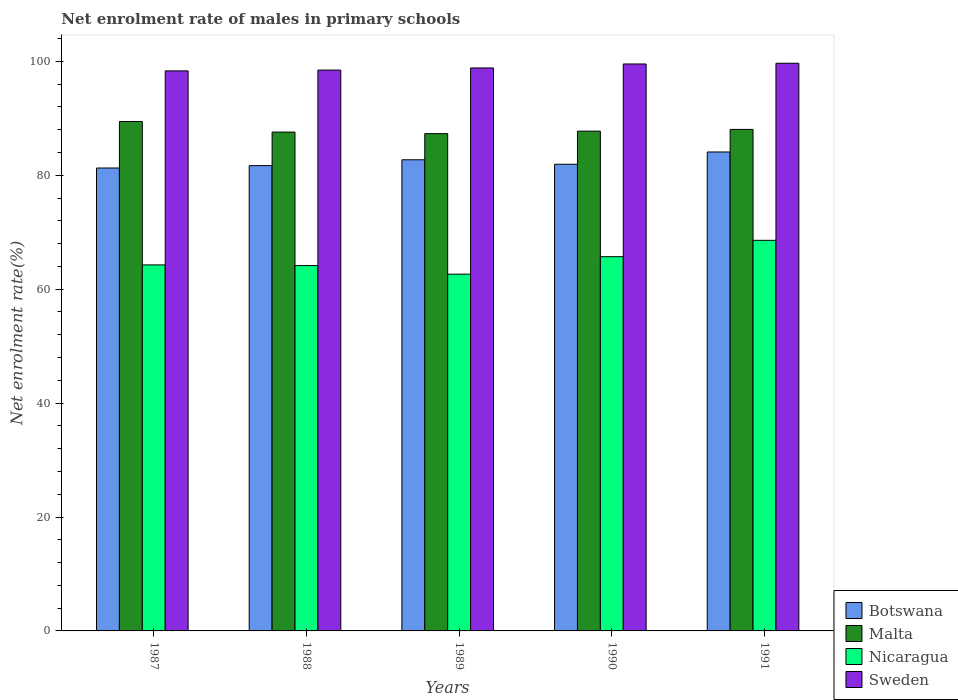How many groups of bars are there?
Your answer should be compact. 5. Are the number of bars on each tick of the X-axis equal?
Provide a short and direct response. Yes. How many bars are there on the 4th tick from the right?
Offer a terse response. 4. What is the label of the 3rd group of bars from the left?
Provide a succinct answer. 1989. What is the net enrolment rate of males in primary schools in Botswana in 1990?
Keep it short and to the point. 81.93. Across all years, what is the maximum net enrolment rate of males in primary schools in Nicaragua?
Ensure brevity in your answer.  68.58. Across all years, what is the minimum net enrolment rate of males in primary schools in Nicaragua?
Your answer should be compact. 62.63. In which year was the net enrolment rate of males in primary schools in Botswana maximum?
Provide a succinct answer. 1991. In which year was the net enrolment rate of males in primary schools in Sweden minimum?
Provide a short and direct response. 1987. What is the total net enrolment rate of males in primary schools in Botswana in the graph?
Provide a succinct answer. 411.7. What is the difference between the net enrolment rate of males in primary schools in Nicaragua in 1989 and that in 1991?
Offer a very short reply. -5.94. What is the difference between the net enrolment rate of males in primary schools in Botswana in 1988 and the net enrolment rate of males in primary schools in Sweden in 1990?
Your answer should be compact. -17.84. What is the average net enrolment rate of males in primary schools in Nicaragua per year?
Ensure brevity in your answer.  65.06. In the year 1991, what is the difference between the net enrolment rate of males in primary schools in Sweden and net enrolment rate of males in primary schools in Malta?
Offer a very short reply. 11.62. In how many years, is the net enrolment rate of males in primary schools in Botswana greater than 92 %?
Your answer should be compact. 0. What is the ratio of the net enrolment rate of males in primary schools in Malta in 1989 to that in 1991?
Offer a terse response. 0.99. Is the net enrolment rate of males in primary schools in Nicaragua in 1990 less than that in 1991?
Make the answer very short. Yes. What is the difference between the highest and the second highest net enrolment rate of males in primary schools in Nicaragua?
Ensure brevity in your answer.  2.87. What is the difference between the highest and the lowest net enrolment rate of males in primary schools in Botswana?
Provide a short and direct response. 2.81. In how many years, is the net enrolment rate of males in primary schools in Malta greater than the average net enrolment rate of males in primary schools in Malta taken over all years?
Your response must be concise. 2. Is the sum of the net enrolment rate of males in primary schools in Malta in 1988 and 1989 greater than the maximum net enrolment rate of males in primary schools in Sweden across all years?
Give a very brief answer. Yes. What does the 4th bar from the right in 1989 represents?
Offer a very short reply. Botswana. How many bars are there?
Your response must be concise. 20. Are all the bars in the graph horizontal?
Keep it short and to the point. No. How many years are there in the graph?
Give a very brief answer. 5. Are the values on the major ticks of Y-axis written in scientific E-notation?
Your answer should be compact. No. How many legend labels are there?
Give a very brief answer. 4. What is the title of the graph?
Your answer should be very brief. Net enrolment rate of males in primary schools. What is the label or title of the Y-axis?
Offer a very short reply. Net enrolment rate(%). What is the Net enrolment rate(%) in Botswana in 1987?
Offer a very short reply. 81.27. What is the Net enrolment rate(%) in Malta in 1987?
Provide a succinct answer. 89.44. What is the Net enrolment rate(%) of Nicaragua in 1987?
Ensure brevity in your answer.  64.26. What is the Net enrolment rate(%) of Sweden in 1987?
Keep it short and to the point. 98.32. What is the Net enrolment rate(%) in Botswana in 1988?
Your response must be concise. 81.69. What is the Net enrolment rate(%) in Malta in 1988?
Your answer should be compact. 87.58. What is the Net enrolment rate(%) of Nicaragua in 1988?
Offer a terse response. 64.14. What is the Net enrolment rate(%) in Sweden in 1988?
Your answer should be compact. 98.47. What is the Net enrolment rate(%) of Botswana in 1989?
Keep it short and to the point. 82.72. What is the Net enrolment rate(%) in Malta in 1989?
Your answer should be very brief. 87.31. What is the Net enrolment rate(%) of Nicaragua in 1989?
Offer a terse response. 62.63. What is the Net enrolment rate(%) in Sweden in 1989?
Your response must be concise. 98.84. What is the Net enrolment rate(%) in Botswana in 1990?
Provide a short and direct response. 81.93. What is the Net enrolment rate(%) in Malta in 1990?
Your response must be concise. 87.74. What is the Net enrolment rate(%) of Nicaragua in 1990?
Your response must be concise. 65.71. What is the Net enrolment rate(%) in Sweden in 1990?
Give a very brief answer. 99.54. What is the Net enrolment rate(%) in Botswana in 1991?
Make the answer very short. 84.09. What is the Net enrolment rate(%) in Malta in 1991?
Keep it short and to the point. 88.05. What is the Net enrolment rate(%) in Nicaragua in 1991?
Ensure brevity in your answer.  68.58. What is the Net enrolment rate(%) in Sweden in 1991?
Your answer should be compact. 99.66. Across all years, what is the maximum Net enrolment rate(%) of Botswana?
Your answer should be very brief. 84.09. Across all years, what is the maximum Net enrolment rate(%) of Malta?
Provide a succinct answer. 89.44. Across all years, what is the maximum Net enrolment rate(%) of Nicaragua?
Your response must be concise. 68.58. Across all years, what is the maximum Net enrolment rate(%) in Sweden?
Your response must be concise. 99.66. Across all years, what is the minimum Net enrolment rate(%) of Botswana?
Provide a short and direct response. 81.27. Across all years, what is the minimum Net enrolment rate(%) of Malta?
Keep it short and to the point. 87.31. Across all years, what is the minimum Net enrolment rate(%) in Nicaragua?
Your response must be concise. 62.63. Across all years, what is the minimum Net enrolment rate(%) of Sweden?
Your answer should be very brief. 98.32. What is the total Net enrolment rate(%) of Botswana in the graph?
Give a very brief answer. 411.7. What is the total Net enrolment rate(%) in Malta in the graph?
Your response must be concise. 440.12. What is the total Net enrolment rate(%) of Nicaragua in the graph?
Ensure brevity in your answer.  325.31. What is the total Net enrolment rate(%) of Sweden in the graph?
Provide a short and direct response. 494.83. What is the difference between the Net enrolment rate(%) in Botswana in 1987 and that in 1988?
Ensure brevity in your answer.  -0.42. What is the difference between the Net enrolment rate(%) of Malta in 1987 and that in 1988?
Your answer should be compact. 1.86. What is the difference between the Net enrolment rate(%) of Nicaragua in 1987 and that in 1988?
Keep it short and to the point. 0.12. What is the difference between the Net enrolment rate(%) of Sweden in 1987 and that in 1988?
Provide a succinct answer. -0.14. What is the difference between the Net enrolment rate(%) in Botswana in 1987 and that in 1989?
Offer a terse response. -1.44. What is the difference between the Net enrolment rate(%) in Malta in 1987 and that in 1989?
Offer a terse response. 2.13. What is the difference between the Net enrolment rate(%) in Nicaragua in 1987 and that in 1989?
Provide a succinct answer. 1.62. What is the difference between the Net enrolment rate(%) of Sweden in 1987 and that in 1989?
Make the answer very short. -0.52. What is the difference between the Net enrolment rate(%) of Botswana in 1987 and that in 1990?
Provide a short and direct response. -0.66. What is the difference between the Net enrolment rate(%) of Malta in 1987 and that in 1990?
Your answer should be very brief. 1.7. What is the difference between the Net enrolment rate(%) in Nicaragua in 1987 and that in 1990?
Ensure brevity in your answer.  -1.45. What is the difference between the Net enrolment rate(%) in Sweden in 1987 and that in 1990?
Keep it short and to the point. -1.21. What is the difference between the Net enrolment rate(%) of Botswana in 1987 and that in 1991?
Provide a short and direct response. -2.81. What is the difference between the Net enrolment rate(%) in Malta in 1987 and that in 1991?
Your response must be concise. 1.39. What is the difference between the Net enrolment rate(%) in Nicaragua in 1987 and that in 1991?
Provide a succinct answer. -4.32. What is the difference between the Net enrolment rate(%) of Sweden in 1987 and that in 1991?
Offer a very short reply. -1.34. What is the difference between the Net enrolment rate(%) in Botswana in 1988 and that in 1989?
Your answer should be very brief. -1.03. What is the difference between the Net enrolment rate(%) of Malta in 1988 and that in 1989?
Keep it short and to the point. 0.27. What is the difference between the Net enrolment rate(%) in Nicaragua in 1988 and that in 1989?
Give a very brief answer. 1.5. What is the difference between the Net enrolment rate(%) of Sweden in 1988 and that in 1989?
Give a very brief answer. -0.37. What is the difference between the Net enrolment rate(%) of Botswana in 1988 and that in 1990?
Your response must be concise. -0.24. What is the difference between the Net enrolment rate(%) of Malta in 1988 and that in 1990?
Give a very brief answer. -0.17. What is the difference between the Net enrolment rate(%) of Nicaragua in 1988 and that in 1990?
Keep it short and to the point. -1.57. What is the difference between the Net enrolment rate(%) of Sweden in 1988 and that in 1990?
Provide a short and direct response. -1.07. What is the difference between the Net enrolment rate(%) in Botswana in 1988 and that in 1991?
Keep it short and to the point. -2.39. What is the difference between the Net enrolment rate(%) in Malta in 1988 and that in 1991?
Offer a very short reply. -0.47. What is the difference between the Net enrolment rate(%) in Nicaragua in 1988 and that in 1991?
Offer a very short reply. -4.44. What is the difference between the Net enrolment rate(%) in Sweden in 1988 and that in 1991?
Make the answer very short. -1.2. What is the difference between the Net enrolment rate(%) of Botswana in 1989 and that in 1990?
Give a very brief answer. 0.79. What is the difference between the Net enrolment rate(%) in Malta in 1989 and that in 1990?
Ensure brevity in your answer.  -0.44. What is the difference between the Net enrolment rate(%) in Nicaragua in 1989 and that in 1990?
Ensure brevity in your answer.  -3.07. What is the difference between the Net enrolment rate(%) of Sweden in 1989 and that in 1990?
Provide a short and direct response. -0.7. What is the difference between the Net enrolment rate(%) in Botswana in 1989 and that in 1991?
Offer a terse response. -1.37. What is the difference between the Net enrolment rate(%) in Malta in 1989 and that in 1991?
Make the answer very short. -0.74. What is the difference between the Net enrolment rate(%) of Nicaragua in 1989 and that in 1991?
Provide a short and direct response. -5.94. What is the difference between the Net enrolment rate(%) of Sweden in 1989 and that in 1991?
Keep it short and to the point. -0.82. What is the difference between the Net enrolment rate(%) in Botswana in 1990 and that in 1991?
Ensure brevity in your answer.  -2.16. What is the difference between the Net enrolment rate(%) of Malta in 1990 and that in 1991?
Keep it short and to the point. -0.3. What is the difference between the Net enrolment rate(%) in Nicaragua in 1990 and that in 1991?
Your answer should be compact. -2.87. What is the difference between the Net enrolment rate(%) in Sweden in 1990 and that in 1991?
Provide a succinct answer. -0.13. What is the difference between the Net enrolment rate(%) of Botswana in 1987 and the Net enrolment rate(%) of Malta in 1988?
Ensure brevity in your answer.  -6.3. What is the difference between the Net enrolment rate(%) in Botswana in 1987 and the Net enrolment rate(%) in Nicaragua in 1988?
Make the answer very short. 17.13. What is the difference between the Net enrolment rate(%) of Botswana in 1987 and the Net enrolment rate(%) of Sweden in 1988?
Keep it short and to the point. -17.19. What is the difference between the Net enrolment rate(%) of Malta in 1987 and the Net enrolment rate(%) of Nicaragua in 1988?
Your response must be concise. 25.3. What is the difference between the Net enrolment rate(%) of Malta in 1987 and the Net enrolment rate(%) of Sweden in 1988?
Offer a very short reply. -9.03. What is the difference between the Net enrolment rate(%) of Nicaragua in 1987 and the Net enrolment rate(%) of Sweden in 1988?
Make the answer very short. -34.21. What is the difference between the Net enrolment rate(%) in Botswana in 1987 and the Net enrolment rate(%) in Malta in 1989?
Give a very brief answer. -6.03. What is the difference between the Net enrolment rate(%) in Botswana in 1987 and the Net enrolment rate(%) in Nicaragua in 1989?
Your response must be concise. 18.64. What is the difference between the Net enrolment rate(%) in Botswana in 1987 and the Net enrolment rate(%) in Sweden in 1989?
Give a very brief answer. -17.57. What is the difference between the Net enrolment rate(%) in Malta in 1987 and the Net enrolment rate(%) in Nicaragua in 1989?
Your answer should be compact. 26.81. What is the difference between the Net enrolment rate(%) in Malta in 1987 and the Net enrolment rate(%) in Sweden in 1989?
Give a very brief answer. -9.4. What is the difference between the Net enrolment rate(%) in Nicaragua in 1987 and the Net enrolment rate(%) in Sweden in 1989?
Offer a very short reply. -34.58. What is the difference between the Net enrolment rate(%) in Botswana in 1987 and the Net enrolment rate(%) in Malta in 1990?
Your answer should be very brief. -6.47. What is the difference between the Net enrolment rate(%) of Botswana in 1987 and the Net enrolment rate(%) of Nicaragua in 1990?
Ensure brevity in your answer.  15.57. What is the difference between the Net enrolment rate(%) in Botswana in 1987 and the Net enrolment rate(%) in Sweden in 1990?
Your answer should be compact. -18.26. What is the difference between the Net enrolment rate(%) of Malta in 1987 and the Net enrolment rate(%) of Nicaragua in 1990?
Offer a terse response. 23.74. What is the difference between the Net enrolment rate(%) in Malta in 1987 and the Net enrolment rate(%) in Sweden in 1990?
Make the answer very short. -10.09. What is the difference between the Net enrolment rate(%) of Nicaragua in 1987 and the Net enrolment rate(%) of Sweden in 1990?
Make the answer very short. -35.28. What is the difference between the Net enrolment rate(%) in Botswana in 1987 and the Net enrolment rate(%) in Malta in 1991?
Provide a succinct answer. -6.77. What is the difference between the Net enrolment rate(%) in Botswana in 1987 and the Net enrolment rate(%) in Nicaragua in 1991?
Your answer should be compact. 12.7. What is the difference between the Net enrolment rate(%) of Botswana in 1987 and the Net enrolment rate(%) of Sweden in 1991?
Your response must be concise. -18.39. What is the difference between the Net enrolment rate(%) of Malta in 1987 and the Net enrolment rate(%) of Nicaragua in 1991?
Your answer should be compact. 20.87. What is the difference between the Net enrolment rate(%) of Malta in 1987 and the Net enrolment rate(%) of Sweden in 1991?
Offer a terse response. -10.22. What is the difference between the Net enrolment rate(%) in Nicaragua in 1987 and the Net enrolment rate(%) in Sweden in 1991?
Your answer should be compact. -35.4. What is the difference between the Net enrolment rate(%) of Botswana in 1988 and the Net enrolment rate(%) of Malta in 1989?
Make the answer very short. -5.62. What is the difference between the Net enrolment rate(%) of Botswana in 1988 and the Net enrolment rate(%) of Nicaragua in 1989?
Provide a short and direct response. 19.06. What is the difference between the Net enrolment rate(%) in Botswana in 1988 and the Net enrolment rate(%) in Sweden in 1989?
Ensure brevity in your answer.  -17.15. What is the difference between the Net enrolment rate(%) of Malta in 1988 and the Net enrolment rate(%) of Nicaragua in 1989?
Your response must be concise. 24.94. What is the difference between the Net enrolment rate(%) of Malta in 1988 and the Net enrolment rate(%) of Sweden in 1989?
Offer a terse response. -11.26. What is the difference between the Net enrolment rate(%) in Nicaragua in 1988 and the Net enrolment rate(%) in Sweden in 1989?
Offer a very short reply. -34.7. What is the difference between the Net enrolment rate(%) in Botswana in 1988 and the Net enrolment rate(%) in Malta in 1990?
Your answer should be very brief. -6.05. What is the difference between the Net enrolment rate(%) in Botswana in 1988 and the Net enrolment rate(%) in Nicaragua in 1990?
Your answer should be compact. 15.99. What is the difference between the Net enrolment rate(%) of Botswana in 1988 and the Net enrolment rate(%) of Sweden in 1990?
Keep it short and to the point. -17.84. What is the difference between the Net enrolment rate(%) of Malta in 1988 and the Net enrolment rate(%) of Nicaragua in 1990?
Provide a short and direct response. 21.87. What is the difference between the Net enrolment rate(%) of Malta in 1988 and the Net enrolment rate(%) of Sweden in 1990?
Provide a short and direct response. -11.96. What is the difference between the Net enrolment rate(%) in Nicaragua in 1988 and the Net enrolment rate(%) in Sweden in 1990?
Your answer should be compact. -35.4. What is the difference between the Net enrolment rate(%) of Botswana in 1988 and the Net enrolment rate(%) of Malta in 1991?
Make the answer very short. -6.36. What is the difference between the Net enrolment rate(%) of Botswana in 1988 and the Net enrolment rate(%) of Nicaragua in 1991?
Make the answer very short. 13.12. What is the difference between the Net enrolment rate(%) in Botswana in 1988 and the Net enrolment rate(%) in Sweden in 1991?
Your response must be concise. -17.97. What is the difference between the Net enrolment rate(%) of Malta in 1988 and the Net enrolment rate(%) of Nicaragua in 1991?
Your response must be concise. 19. What is the difference between the Net enrolment rate(%) in Malta in 1988 and the Net enrolment rate(%) in Sweden in 1991?
Give a very brief answer. -12.08. What is the difference between the Net enrolment rate(%) of Nicaragua in 1988 and the Net enrolment rate(%) of Sweden in 1991?
Ensure brevity in your answer.  -35.52. What is the difference between the Net enrolment rate(%) of Botswana in 1989 and the Net enrolment rate(%) of Malta in 1990?
Make the answer very short. -5.03. What is the difference between the Net enrolment rate(%) in Botswana in 1989 and the Net enrolment rate(%) in Nicaragua in 1990?
Offer a very short reply. 17.01. What is the difference between the Net enrolment rate(%) of Botswana in 1989 and the Net enrolment rate(%) of Sweden in 1990?
Provide a short and direct response. -16.82. What is the difference between the Net enrolment rate(%) in Malta in 1989 and the Net enrolment rate(%) in Nicaragua in 1990?
Provide a succinct answer. 21.6. What is the difference between the Net enrolment rate(%) in Malta in 1989 and the Net enrolment rate(%) in Sweden in 1990?
Your response must be concise. -12.23. What is the difference between the Net enrolment rate(%) of Nicaragua in 1989 and the Net enrolment rate(%) of Sweden in 1990?
Ensure brevity in your answer.  -36.9. What is the difference between the Net enrolment rate(%) in Botswana in 1989 and the Net enrolment rate(%) in Malta in 1991?
Your answer should be very brief. -5.33. What is the difference between the Net enrolment rate(%) of Botswana in 1989 and the Net enrolment rate(%) of Nicaragua in 1991?
Provide a short and direct response. 14.14. What is the difference between the Net enrolment rate(%) in Botswana in 1989 and the Net enrolment rate(%) in Sweden in 1991?
Your answer should be compact. -16.95. What is the difference between the Net enrolment rate(%) in Malta in 1989 and the Net enrolment rate(%) in Nicaragua in 1991?
Keep it short and to the point. 18.73. What is the difference between the Net enrolment rate(%) in Malta in 1989 and the Net enrolment rate(%) in Sweden in 1991?
Give a very brief answer. -12.36. What is the difference between the Net enrolment rate(%) in Nicaragua in 1989 and the Net enrolment rate(%) in Sweden in 1991?
Your response must be concise. -37.03. What is the difference between the Net enrolment rate(%) in Botswana in 1990 and the Net enrolment rate(%) in Malta in 1991?
Give a very brief answer. -6.12. What is the difference between the Net enrolment rate(%) in Botswana in 1990 and the Net enrolment rate(%) in Nicaragua in 1991?
Make the answer very short. 13.36. What is the difference between the Net enrolment rate(%) of Botswana in 1990 and the Net enrolment rate(%) of Sweden in 1991?
Provide a succinct answer. -17.73. What is the difference between the Net enrolment rate(%) of Malta in 1990 and the Net enrolment rate(%) of Nicaragua in 1991?
Provide a succinct answer. 19.17. What is the difference between the Net enrolment rate(%) of Malta in 1990 and the Net enrolment rate(%) of Sweden in 1991?
Your answer should be compact. -11.92. What is the difference between the Net enrolment rate(%) in Nicaragua in 1990 and the Net enrolment rate(%) in Sweden in 1991?
Make the answer very short. -33.96. What is the average Net enrolment rate(%) of Botswana per year?
Ensure brevity in your answer.  82.34. What is the average Net enrolment rate(%) of Malta per year?
Your answer should be compact. 88.02. What is the average Net enrolment rate(%) of Nicaragua per year?
Your answer should be very brief. 65.06. What is the average Net enrolment rate(%) in Sweden per year?
Provide a short and direct response. 98.97. In the year 1987, what is the difference between the Net enrolment rate(%) in Botswana and Net enrolment rate(%) in Malta?
Offer a very short reply. -8.17. In the year 1987, what is the difference between the Net enrolment rate(%) in Botswana and Net enrolment rate(%) in Nicaragua?
Your answer should be compact. 17.01. In the year 1987, what is the difference between the Net enrolment rate(%) in Botswana and Net enrolment rate(%) in Sweden?
Offer a terse response. -17.05. In the year 1987, what is the difference between the Net enrolment rate(%) of Malta and Net enrolment rate(%) of Nicaragua?
Offer a very short reply. 25.18. In the year 1987, what is the difference between the Net enrolment rate(%) in Malta and Net enrolment rate(%) in Sweden?
Make the answer very short. -8.88. In the year 1987, what is the difference between the Net enrolment rate(%) in Nicaragua and Net enrolment rate(%) in Sweden?
Your answer should be very brief. -34.06. In the year 1988, what is the difference between the Net enrolment rate(%) of Botswana and Net enrolment rate(%) of Malta?
Your response must be concise. -5.89. In the year 1988, what is the difference between the Net enrolment rate(%) of Botswana and Net enrolment rate(%) of Nicaragua?
Your answer should be very brief. 17.55. In the year 1988, what is the difference between the Net enrolment rate(%) of Botswana and Net enrolment rate(%) of Sweden?
Provide a succinct answer. -16.78. In the year 1988, what is the difference between the Net enrolment rate(%) of Malta and Net enrolment rate(%) of Nicaragua?
Offer a very short reply. 23.44. In the year 1988, what is the difference between the Net enrolment rate(%) in Malta and Net enrolment rate(%) in Sweden?
Ensure brevity in your answer.  -10.89. In the year 1988, what is the difference between the Net enrolment rate(%) of Nicaragua and Net enrolment rate(%) of Sweden?
Provide a succinct answer. -34.33. In the year 1989, what is the difference between the Net enrolment rate(%) of Botswana and Net enrolment rate(%) of Malta?
Provide a succinct answer. -4.59. In the year 1989, what is the difference between the Net enrolment rate(%) of Botswana and Net enrolment rate(%) of Nicaragua?
Provide a succinct answer. 20.08. In the year 1989, what is the difference between the Net enrolment rate(%) in Botswana and Net enrolment rate(%) in Sweden?
Keep it short and to the point. -16.12. In the year 1989, what is the difference between the Net enrolment rate(%) of Malta and Net enrolment rate(%) of Nicaragua?
Provide a short and direct response. 24.67. In the year 1989, what is the difference between the Net enrolment rate(%) of Malta and Net enrolment rate(%) of Sweden?
Make the answer very short. -11.53. In the year 1989, what is the difference between the Net enrolment rate(%) of Nicaragua and Net enrolment rate(%) of Sweden?
Your answer should be very brief. -36.2. In the year 1990, what is the difference between the Net enrolment rate(%) in Botswana and Net enrolment rate(%) in Malta?
Ensure brevity in your answer.  -5.81. In the year 1990, what is the difference between the Net enrolment rate(%) of Botswana and Net enrolment rate(%) of Nicaragua?
Provide a succinct answer. 16.23. In the year 1990, what is the difference between the Net enrolment rate(%) in Botswana and Net enrolment rate(%) in Sweden?
Give a very brief answer. -17.61. In the year 1990, what is the difference between the Net enrolment rate(%) of Malta and Net enrolment rate(%) of Nicaragua?
Provide a short and direct response. 22.04. In the year 1990, what is the difference between the Net enrolment rate(%) of Malta and Net enrolment rate(%) of Sweden?
Keep it short and to the point. -11.79. In the year 1990, what is the difference between the Net enrolment rate(%) of Nicaragua and Net enrolment rate(%) of Sweden?
Keep it short and to the point. -33.83. In the year 1991, what is the difference between the Net enrolment rate(%) of Botswana and Net enrolment rate(%) of Malta?
Provide a short and direct response. -3.96. In the year 1991, what is the difference between the Net enrolment rate(%) of Botswana and Net enrolment rate(%) of Nicaragua?
Provide a short and direct response. 15.51. In the year 1991, what is the difference between the Net enrolment rate(%) in Botswana and Net enrolment rate(%) in Sweden?
Provide a succinct answer. -15.58. In the year 1991, what is the difference between the Net enrolment rate(%) in Malta and Net enrolment rate(%) in Nicaragua?
Offer a terse response. 19.47. In the year 1991, what is the difference between the Net enrolment rate(%) in Malta and Net enrolment rate(%) in Sweden?
Provide a short and direct response. -11.62. In the year 1991, what is the difference between the Net enrolment rate(%) of Nicaragua and Net enrolment rate(%) of Sweden?
Your response must be concise. -31.09. What is the ratio of the Net enrolment rate(%) in Botswana in 1987 to that in 1988?
Offer a very short reply. 0.99. What is the ratio of the Net enrolment rate(%) of Malta in 1987 to that in 1988?
Give a very brief answer. 1.02. What is the ratio of the Net enrolment rate(%) of Sweden in 1987 to that in 1988?
Make the answer very short. 1. What is the ratio of the Net enrolment rate(%) of Botswana in 1987 to that in 1989?
Make the answer very short. 0.98. What is the ratio of the Net enrolment rate(%) of Malta in 1987 to that in 1989?
Provide a succinct answer. 1.02. What is the ratio of the Net enrolment rate(%) in Nicaragua in 1987 to that in 1989?
Offer a very short reply. 1.03. What is the ratio of the Net enrolment rate(%) in Sweden in 1987 to that in 1989?
Offer a very short reply. 0.99. What is the ratio of the Net enrolment rate(%) in Botswana in 1987 to that in 1990?
Your response must be concise. 0.99. What is the ratio of the Net enrolment rate(%) of Malta in 1987 to that in 1990?
Offer a very short reply. 1.02. What is the ratio of the Net enrolment rate(%) in Nicaragua in 1987 to that in 1990?
Your answer should be compact. 0.98. What is the ratio of the Net enrolment rate(%) of Sweden in 1987 to that in 1990?
Provide a succinct answer. 0.99. What is the ratio of the Net enrolment rate(%) in Botswana in 1987 to that in 1991?
Give a very brief answer. 0.97. What is the ratio of the Net enrolment rate(%) of Malta in 1987 to that in 1991?
Make the answer very short. 1.02. What is the ratio of the Net enrolment rate(%) of Nicaragua in 1987 to that in 1991?
Your answer should be very brief. 0.94. What is the ratio of the Net enrolment rate(%) of Sweden in 1987 to that in 1991?
Ensure brevity in your answer.  0.99. What is the ratio of the Net enrolment rate(%) in Botswana in 1988 to that in 1989?
Ensure brevity in your answer.  0.99. What is the ratio of the Net enrolment rate(%) of Botswana in 1988 to that in 1990?
Your answer should be very brief. 1. What is the ratio of the Net enrolment rate(%) in Nicaragua in 1988 to that in 1990?
Your answer should be compact. 0.98. What is the ratio of the Net enrolment rate(%) in Sweden in 1988 to that in 1990?
Offer a very short reply. 0.99. What is the ratio of the Net enrolment rate(%) of Botswana in 1988 to that in 1991?
Offer a very short reply. 0.97. What is the ratio of the Net enrolment rate(%) in Malta in 1988 to that in 1991?
Offer a very short reply. 0.99. What is the ratio of the Net enrolment rate(%) of Nicaragua in 1988 to that in 1991?
Your answer should be very brief. 0.94. What is the ratio of the Net enrolment rate(%) of Botswana in 1989 to that in 1990?
Make the answer very short. 1.01. What is the ratio of the Net enrolment rate(%) of Nicaragua in 1989 to that in 1990?
Offer a terse response. 0.95. What is the ratio of the Net enrolment rate(%) in Botswana in 1989 to that in 1991?
Your response must be concise. 0.98. What is the ratio of the Net enrolment rate(%) in Nicaragua in 1989 to that in 1991?
Provide a succinct answer. 0.91. What is the ratio of the Net enrolment rate(%) in Botswana in 1990 to that in 1991?
Your response must be concise. 0.97. What is the ratio of the Net enrolment rate(%) in Malta in 1990 to that in 1991?
Offer a terse response. 1. What is the ratio of the Net enrolment rate(%) of Nicaragua in 1990 to that in 1991?
Provide a succinct answer. 0.96. What is the difference between the highest and the second highest Net enrolment rate(%) in Botswana?
Provide a short and direct response. 1.37. What is the difference between the highest and the second highest Net enrolment rate(%) in Malta?
Keep it short and to the point. 1.39. What is the difference between the highest and the second highest Net enrolment rate(%) in Nicaragua?
Your answer should be compact. 2.87. What is the difference between the highest and the second highest Net enrolment rate(%) in Sweden?
Offer a very short reply. 0.13. What is the difference between the highest and the lowest Net enrolment rate(%) in Botswana?
Provide a short and direct response. 2.81. What is the difference between the highest and the lowest Net enrolment rate(%) in Malta?
Keep it short and to the point. 2.13. What is the difference between the highest and the lowest Net enrolment rate(%) of Nicaragua?
Your answer should be very brief. 5.94. What is the difference between the highest and the lowest Net enrolment rate(%) in Sweden?
Provide a short and direct response. 1.34. 